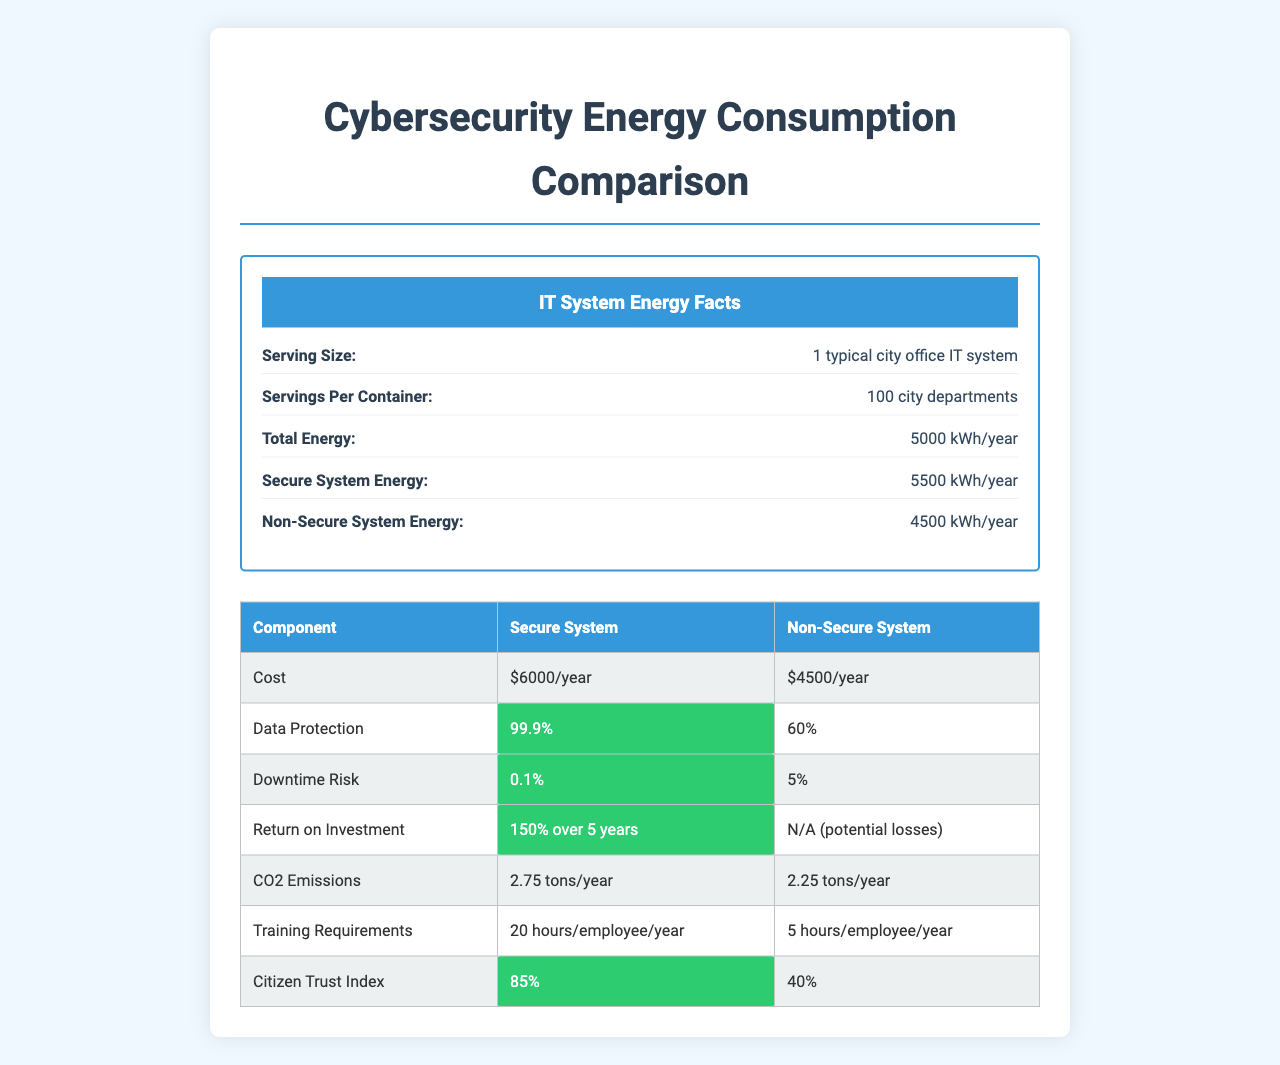what is the serving size? The serving size is mentioned at the beginning of the document: "Serving Size: 1 typical city office IT system".
Answer: 1 typical city office IT system How much energy do secure systems consume per year? The energy consumption for secure systems is listed under the "Secure System Energy" section: "Secure System Energy: 5500 kWh/year".
Answer: 5500 kWh/year What is the difference in downtime risk between secure and non-secure systems? The values are listed under the "Downtime Risk" section: "Secure System: 0.1%", "Non-Secure System: 5%".
Answer: The downtime risk for secure systems is 0.1%, whereas for non-secure systems, it is 5% How much does a secure system cost per year? The cost for a secure system is mentioned under the "Cost Comparison" section: "Secure System: $6000/year".
Answer: $6000/year What is the CO2 emissions difference between secure and non-secure systems? The emissions are listed under "Environmental Impact": "CO2 Emissions (Secure): 2.75 tons/year", "CO2 Emissions (Non-Secure): 2.25 tons/year". The difference is 2.75 - 2.25 = 0.5 tons/year.
Answer: 0.5 tons/year What percentage of the city budget is allocated to IT security? This information can be found in the section titled "City Budget Allocation": "IT Security: 2% of total budget".
Answer: 2% What is the return on investment (ROI) for secure systems over 5 years? The ROI is specified under "Return on Investment": "Secure System: 150% over 5 years".
Answer: 150% Which cybersecurity component uses the least energy per year? Under "Cybersecurity Components", "Multi-Factor Authentication" is listed with "Energy: 50 kWh/year", the lowest among the components.
Answer: Multi-Factor Authentication How accurate is the data protection for non-secure systems? This information is provided under "Data Protection": "Non-Secure System: 60%".
Answer: 60% How many hours of training are required per employee per year for secure systems? The training requirements are detailed under "Training Requirements": "Secure System: 20 hours/employee/year".
Answer: 20 hours Which system has a higher Citizen Trust Index? A. Secure System B. Non-Secure System The Citizen Trust Index is higher for the Secure System (85%) compared to Non-Secure System (40%).
Answer: A How much energy does the firewall component consume per year? A. 100 kWh/year B. 200 kWh/year C. 150 kWh/year The energy consumption for the firewall is specified under "Cybersecurity Components": "Firewall: Energy: 200 kWh/year".
Answer: B Which of the following compliance standards are met only by secure systems? A. GDPR B. HIPAA C. PCI DSS D. All of the above The secure system meets all listed compliance standards: "GDPR: 100% with secure system", "HIPAA: 100% with secure system", "PCI DSS: 100% with secure system".
Answer: D. All of the above Is the energy consumption of secure systems higher than non-secure systems? The document states "Secure System Energy: 5500 kWh/year" and "Non-Secure System Energy: 4500 kWh/year", indicating secure systems consume more energy.
Answer: Yes Summarize the main idea of the document. The explanation includes key comparisons mentioned in the document, such as energy consumption, cost, data protection, compliance, and other pertinent metrics.
Answer: The document compares energy consumption and various other metrics between secure and non-secure IT systems in city offices. It highlights secure systems having higher energy consumption and costs but provides greater data protection, lower downtime risk, compliance with major standards, and higher citizen trust. What is the geographical location of the city being discussed? The document does not provide information on the geographical location of the city.
Answer: Not enough information 